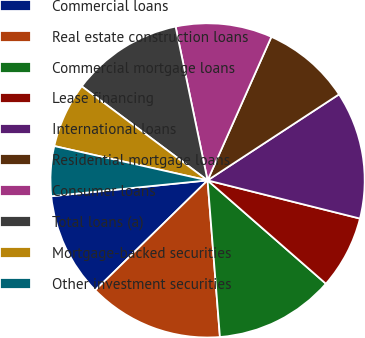Convert chart. <chart><loc_0><loc_0><loc_500><loc_500><pie_chart><fcel>Commercial loans<fcel>Real estate construction loans<fcel>Commercial mortgage loans<fcel>Lease financing<fcel>International loans<fcel>Residential mortgage loans<fcel>Consumer loans<fcel>Total loans (a)<fcel>Mortgage-backed securities<fcel>Other investment securities<nl><fcel>10.72%<fcel>13.93%<fcel>12.32%<fcel>7.52%<fcel>13.13%<fcel>9.12%<fcel>9.92%<fcel>11.52%<fcel>6.71%<fcel>5.11%<nl></chart> 